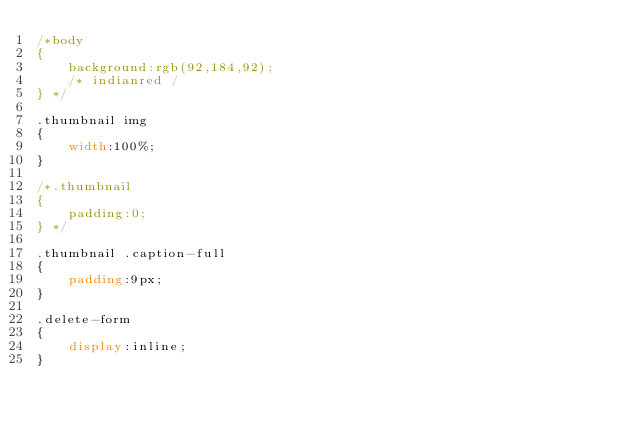Convert code to text. <code><loc_0><loc_0><loc_500><loc_500><_CSS_>/*body
{
    background:rgb(92,184,92);
    /* indianred /
} */

.thumbnail img
{
    width:100%;
} 

/*.thumbnail
{
    padding:0;
} */

.thumbnail .caption-full
{
    padding:9px;
}

.delete-form
{
    display:inline;
}</code> 